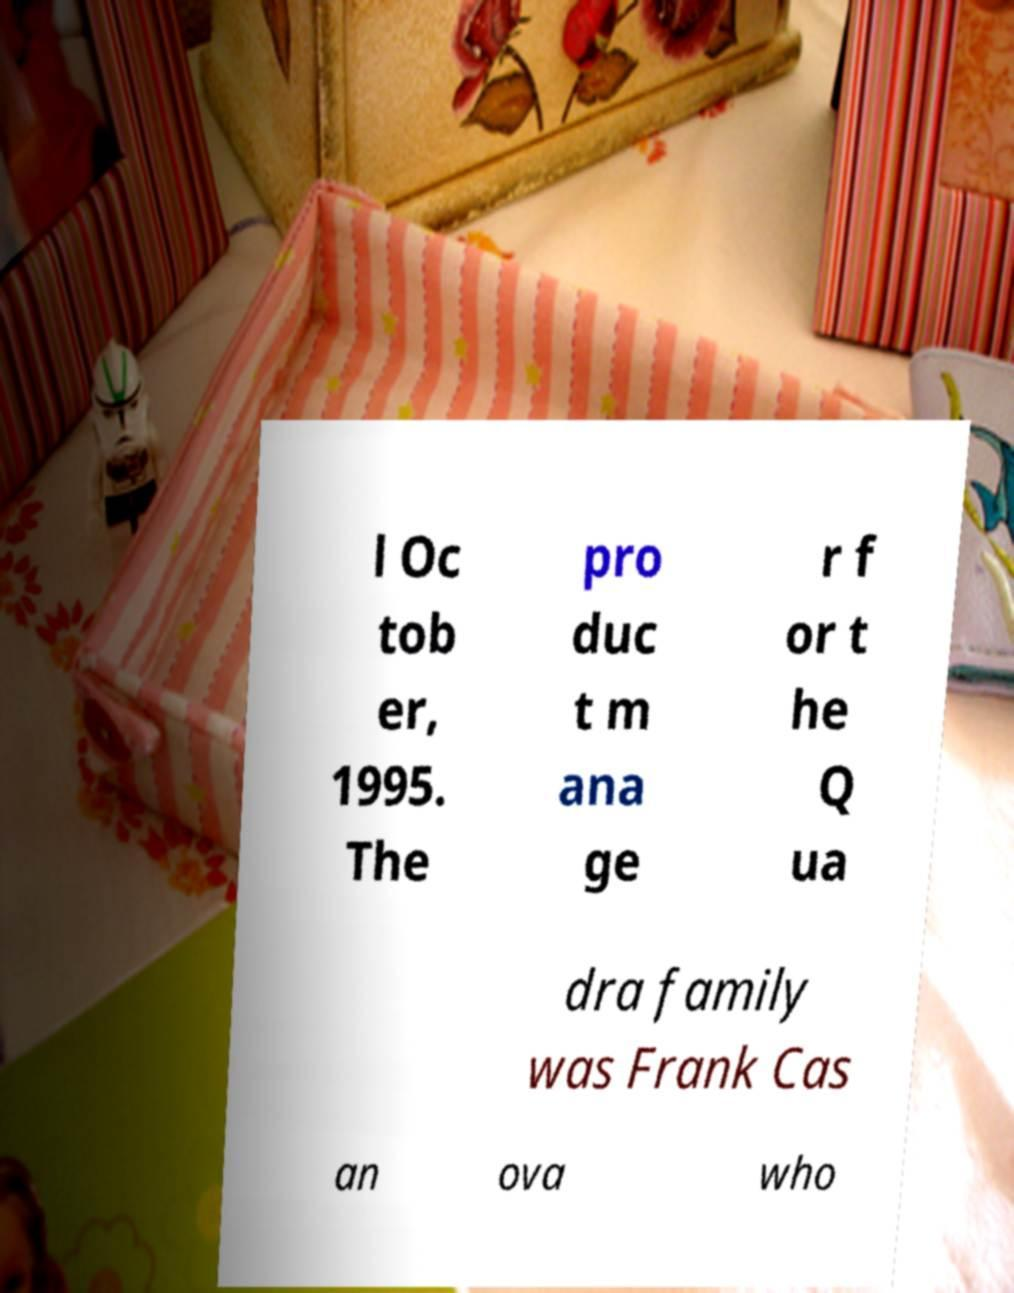Could you assist in decoding the text presented in this image and type it out clearly? l Oc tob er, 1995. The pro duc t m ana ge r f or t he Q ua dra family was Frank Cas an ova who 